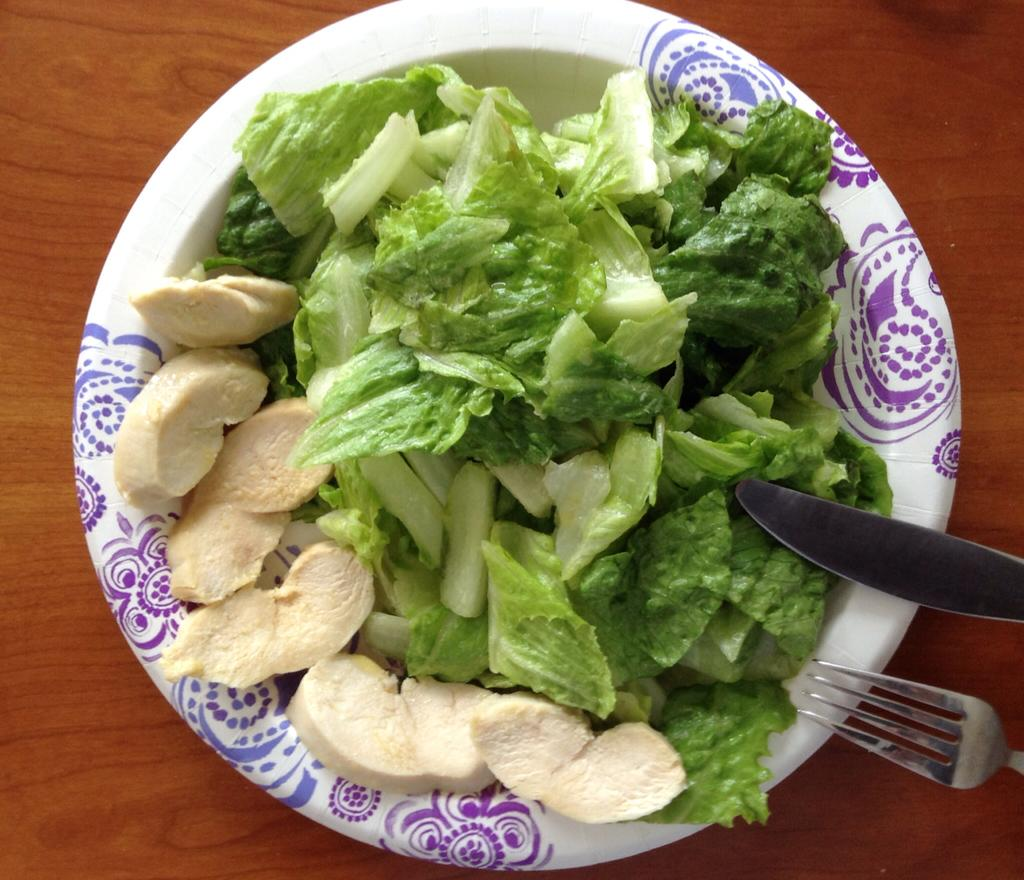What is on the plate that is visible in the image? There are vegetables on the plate. What utensils are present near the plate in the image? There is a knife and a fork on the right side of the plate. What type of surface is at the bottom of the image? There is a wooden surface at the bottom of the image. How many rabbits can be seen playing with the thing on the wooden surface in the image? There are no rabbits or things present in the image; it features a plate with vegetables, utensils, and a wooden surface. 